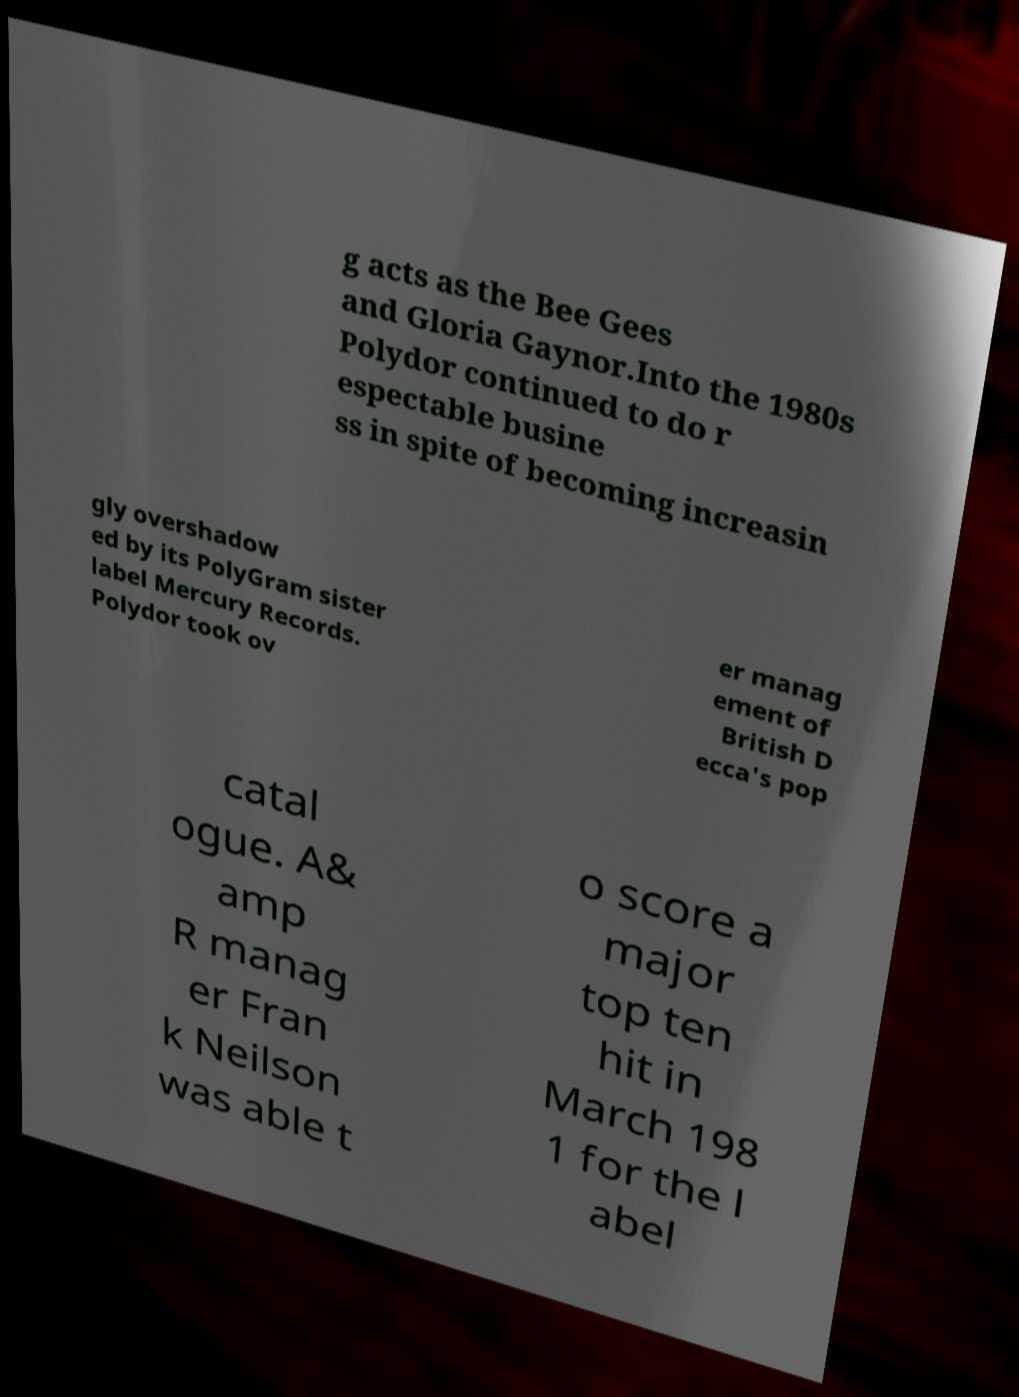Can you accurately transcribe the text from the provided image for me? g acts as the Bee Gees and Gloria Gaynor.Into the 1980s Polydor continued to do r espectable busine ss in spite of becoming increasin gly overshadow ed by its PolyGram sister label Mercury Records. Polydor took ov er manag ement of British D ecca's pop catal ogue. A& amp R manag er Fran k Neilson was able t o score a major top ten hit in March 198 1 for the l abel 